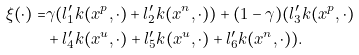Convert formula to latex. <formula><loc_0><loc_0><loc_500><loc_500>\xi ( \cdot ) = & \gamma ( l _ { 1 } ^ { \prime } k ( x ^ { p } , \cdot ) + l _ { 2 } ^ { \prime } k ( x ^ { n } , \cdot ) ) + ( 1 - \gamma ) ( l _ { 3 } ^ { \prime } k ( x ^ { p } , \cdot ) \\ & + l _ { 4 } ^ { \prime } k ( x ^ { u } , \cdot ) + l _ { 5 } ^ { \prime } k ( x ^ { u } , \cdot ) + l _ { 6 } ^ { \prime } k ( x ^ { n } , \cdot ) ) .</formula> 